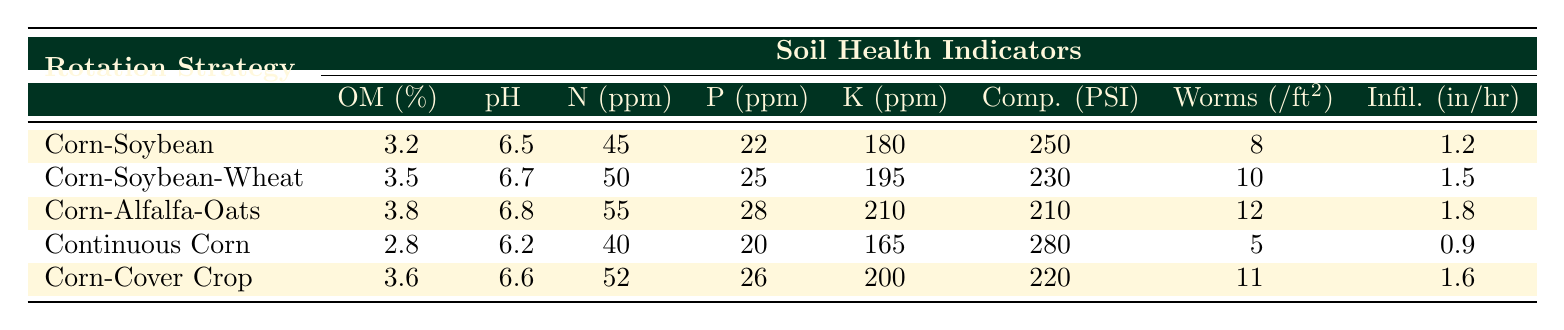What is the Organic Matter percentage in the Corn-Alfalfa-Oats Rotation? The table lists the Organic Matter percentage under the Corn-Alfalfa-Oats Rotation row. The value there is 3.8%
Answer: 3.8% Which rotation strategy has the highest pH level? Looking at the pH level column, the Corn-Alfalfa-Oats Rotation has the highest pH level of 6.8
Answer: Corn-Alfalfa-Oats Rotation What is the difference in Nitrogen content between Continuous Corn and Corn-Soybean-Wheat Rotation? The Nitrogen content for Continuous Corn is 40 ppm, while for Corn-Soybean-Wheat it is 50 ppm. The difference is 50 - 40 = 10 ppm
Answer: 10 ppm Is the Potassium content higher in the Corn-Cover Crop Rotation compared to the Corn-Soybean Rotation? The Potassium content for Corn-Cover Crop is 200 ppm, which is more than Corn-Soybean’s 180 ppm, so the statement is true
Answer: Yes What is the average Water Infiltration Rate for all the rotation strategies listed? The Water Infiltration Rates are 1.2, 1.5, 1.8, 0.9, and 1.6 inches per hour. Adding these gives 1.2 + 1.5 + 1.8 + 0.9 + 1.6 = 7.0. Dividing by 5 gives an average of 7.0 / 5 = 1.4
Answer: 1.4 in/hr Which rotation strategy has the lowest Earthworm Count? The lowest Earthworm Count is in the Continuous Corn row, which shows 5 earthworms per square foot
Answer: Continuous Corn What is the total Phosphorus content for the Corn-Soybean Rotation and the Corn-Cover Crop Rotation? The Phosphorus content for Corn-Soybean Rotation is 22 ppm and for Corn-Cover Crop Rotation is 26 ppm. Adding these gives 22 + 26 = 48 ppm
Answer: 48 ppm If we compare the Soil Compaction values, how much greater is the compaction for Continuous Corn compared to Corn-Alfalfa-Oats? Continuous Corn has a Soil Compaction of 280 PSI, while Corn-Alfalfa-Oats has 210 PSI. The difference is 280 - 210 = 70 PSI, indicating significantly higher compaction
Answer: 70 PSI Are the Organic Matter percentages of Corn-Soybean and Corn-Cover Crop Rotation greater than 3.5%? The Organic Matter for Corn-Soybean is 3.2% and for Corn-Cover Crop is 3.6%. Only Corn-Cover Crop exceeds 3.5%, so the statement is partially true
Answer: No What is the highest value of Nitrogen content among all the rotation strategies? Reviewing the Nitrogen content values, the highest is found under the Corn-Alfalfa-Oats Rotation, which has 55 ppm
Answer: 55 ppm 